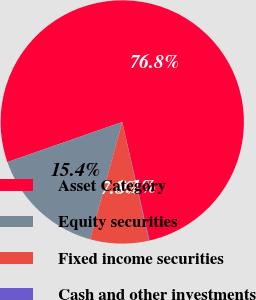Convert chart. <chart><loc_0><loc_0><loc_500><loc_500><pie_chart><fcel>Asset Category<fcel>Equity securities<fcel>Fixed income securities<fcel>Cash and other investments<nl><fcel>76.76%<fcel>15.41%<fcel>7.75%<fcel>0.08%<nl></chart> 